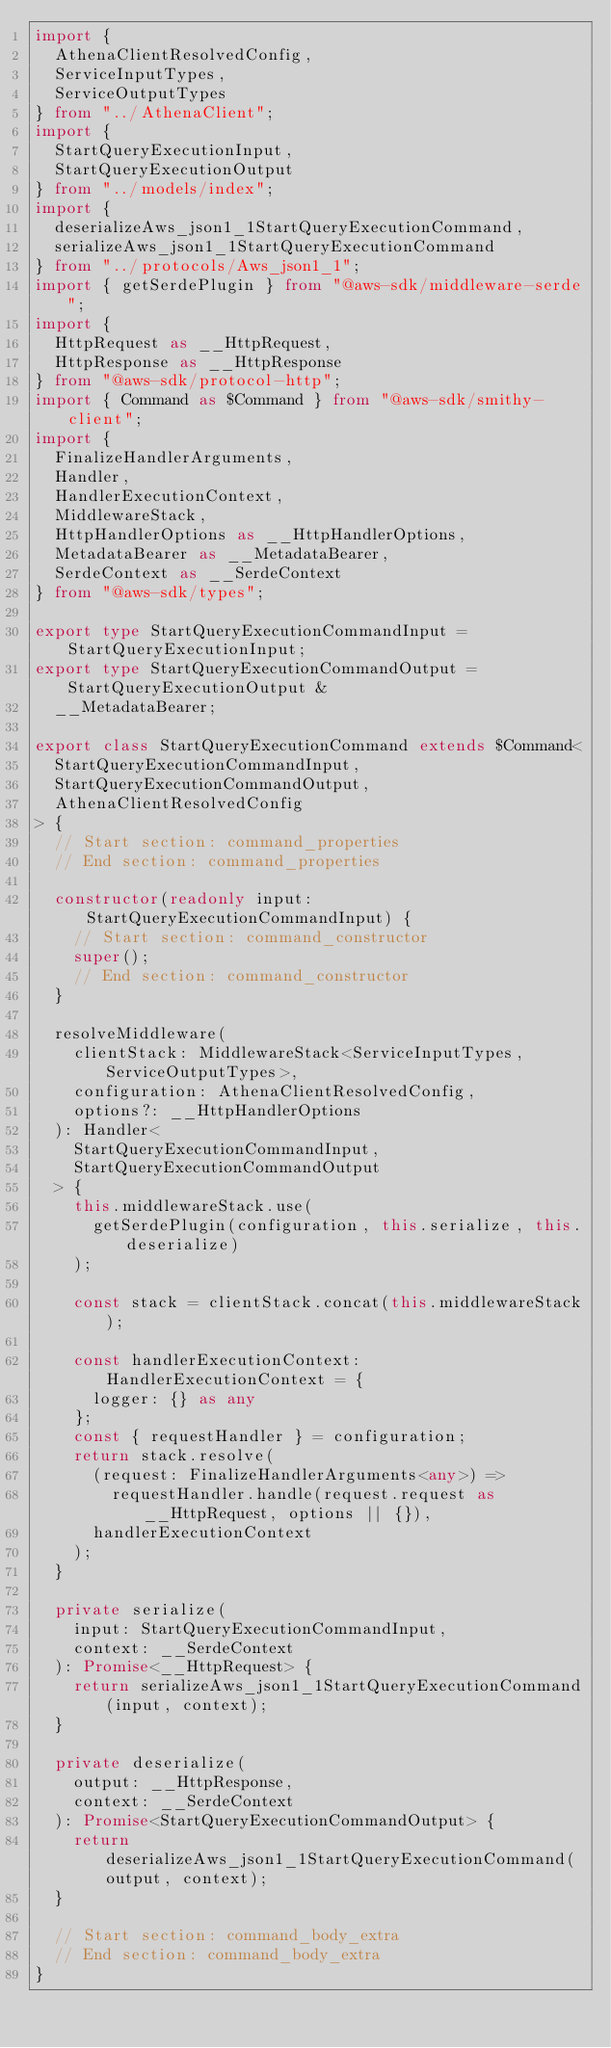<code> <loc_0><loc_0><loc_500><loc_500><_TypeScript_>import {
  AthenaClientResolvedConfig,
  ServiceInputTypes,
  ServiceOutputTypes
} from "../AthenaClient";
import {
  StartQueryExecutionInput,
  StartQueryExecutionOutput
} from "../models/index";
import {
  deserializeAws_json1_1StartQueryExecutionCommand,
  serializeAws_json1_1StartQueryExecutionCommand
} from "../protocols/Aws_json1_1";
import { getSerdePlugin } from "@aws-sdk/middleware-serde";
import {
  HttpRequest as __HttpRequest,
  HttpResponse as __HttpResponse
} from "@aws-sdk/protocol-http";
import { Command as $Command } from "@aws-sdk/smithy-client";
import {
  FinalizeHandlerArguments,
  Handler,
  HandlerExecutionContext,
  MiddlewareStack,
  HttpHandlerOptions as __HttpHandlerOptions,
  MetadataBearer as __MetadataBearer,
  SerdeContext as __SerdeContext
} from "@aws-sdk/types";

export type StartQueryExecutionCommandInput = StartQueryExecutionInput;
export type StartQueryExecutionCommandOutput = StartQueryExecutionOutput &
  __MetadataBearer;

export class StartQueryExecutionCommand extends $Command<
  StartQueryExecutionCommandInput,
  StartQueryExecutionCommandOutput,
  AthenaClientResolvedConfig
> {
  // Start section: command_properties
  // End section: command_properties

  constructor(readonly input: StartQueryExecutionCommandInput) {
    // Start section: command_constructor
    super();
    // End section: command_constructor
  }

  resolveMiddleware(
    clientStack: MiddlewareStack<ServiceInputTypes, ServiceOutputTypes>,
    configuration: AthenaClientResolvedConfig,
    options?: __HttpHandlerOptions
  ): Handler<
    StartQueryExecutionCommandInput,
    StartQueryExecutionCommandOutput
  > {
    this.middlewareStack.use(
      getSerdePlugin(configuration, this.serialize, this.deserialize)
    );

    const stack = clientStack.concat(this.middlewareStack);

    const handlerExecutionContext: HandlerExecutionContext = {
      logger: {} as any
    };
    const { requestHandler } = configuration;
    return stack.resolve(
      (request: FinalizeHandlerArguments<any>) =>
        requestHandler.handle(request.request as __HttpRequest, options || {}),
      handlerExecutionContext
    );
  }

  private serialize(
    input: StartQueryExecutionCommandInput,
    context: __SerdeContext
  ): Promise<__HttpRequest> {
    return serializeAws_json1_1StartQueryExecutionCommand(input, context);
  }

  private deserialize(
    output: __HttpResponse,
    context: __SerdeContext
  ): Promise<StartQueryExecutionCommandOutput> {
    return deserializeAws_json1_1StartQueryExecutionCommand(output, context);
  }

  // Start section: command_body_extra
  // End section: command_body_extra
}
</code> 